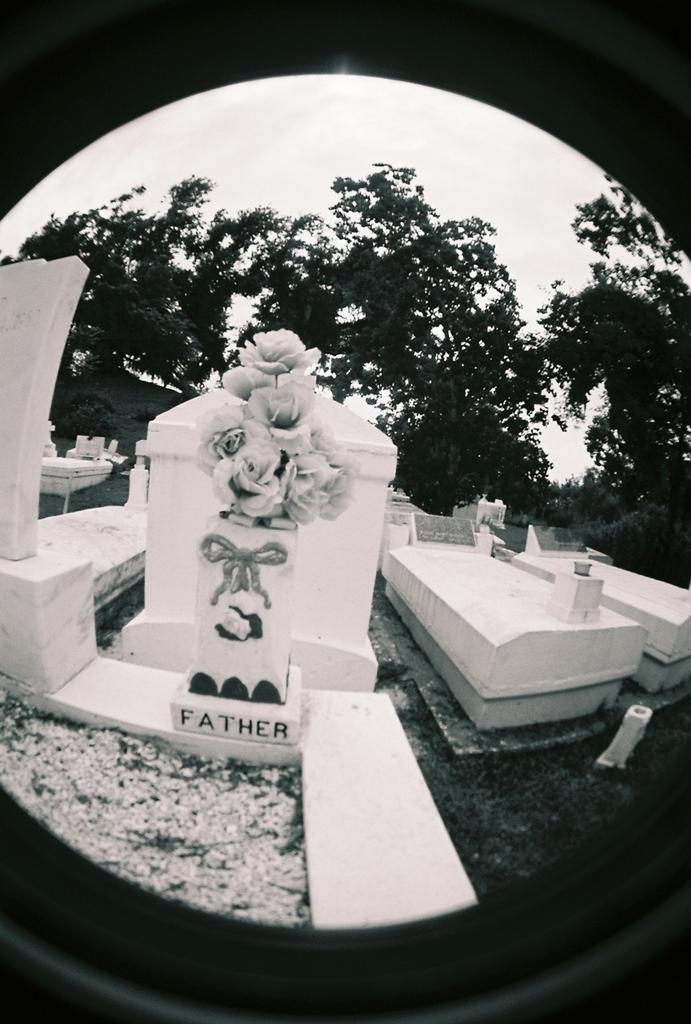How would you summarize this image in a sentence or two? The image is taken in the graveyard. In the center of the image we can see graves. In the background there are trees and sky. 